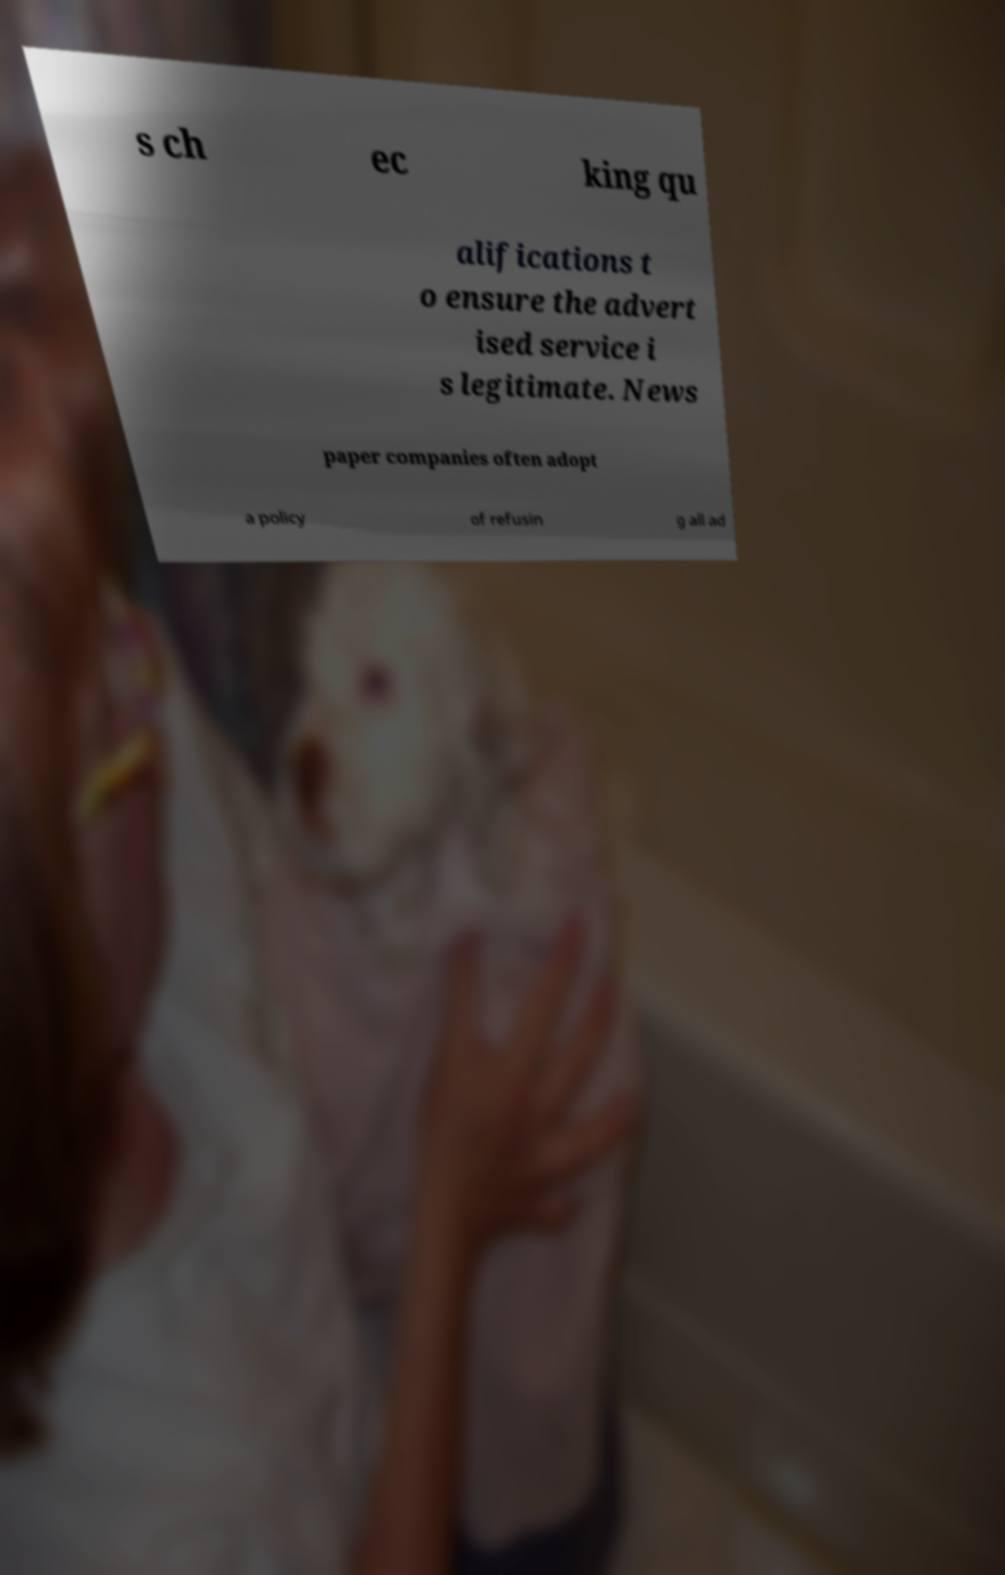Could you assist in decoding the text presented in this image and type it out clearly? s ch ec king qu alifications t o ensure the advert ised service i s legitimate. News paper companies often adopt a policy of refusin g all ad 